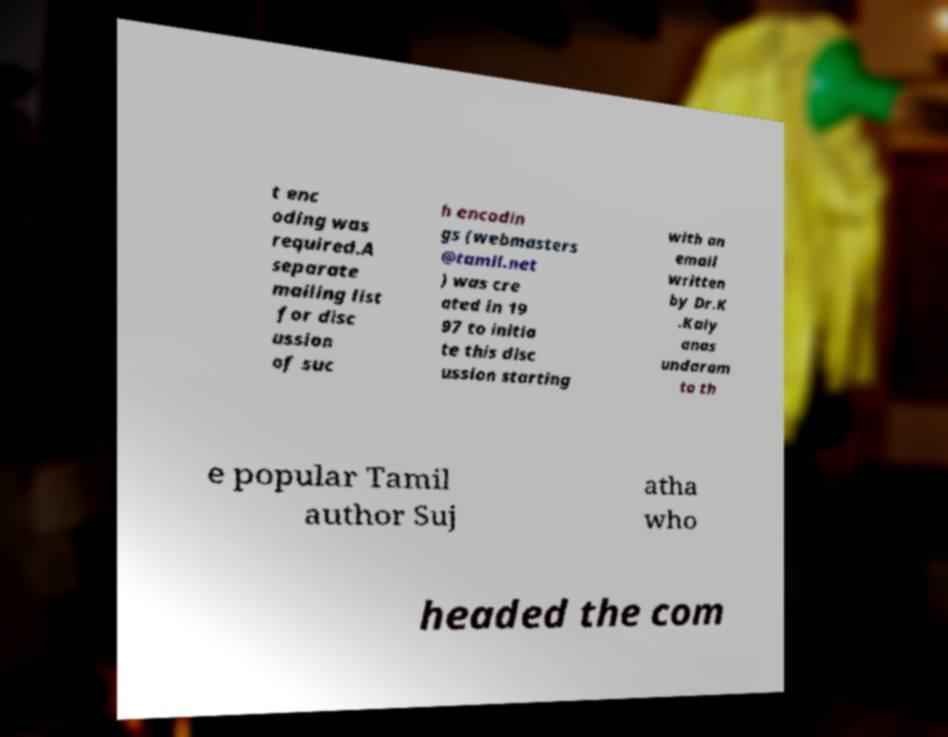What messages or text are displayed in this image? I need them in a readable, typed format. t enc oding was required.A separate mailing list for disc ussion of suc h encodin gs (webmasters @tamil.net ) was cre ated in 19 97 to initia te this disc ussion starting with an email written by Dr.K .Kaly anas undaram to th e popular Tamil author Suj atha who headed the com 